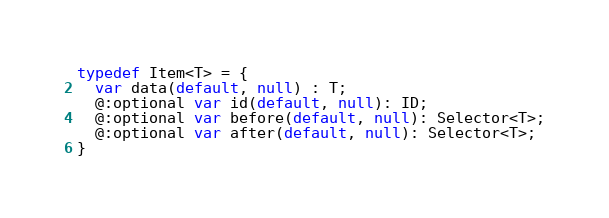Convert code to text. <code><loc_0><loc_0><loc_500><loc_500><_Haxe_>typedef Item<T> = {
  var data(default, null) : T;
  @:optional var id(default, null): ID;
  @:optional var before(default, null): Selector<T>;
  @:optional var after(default, null): Selector<T>;
}  </code> 